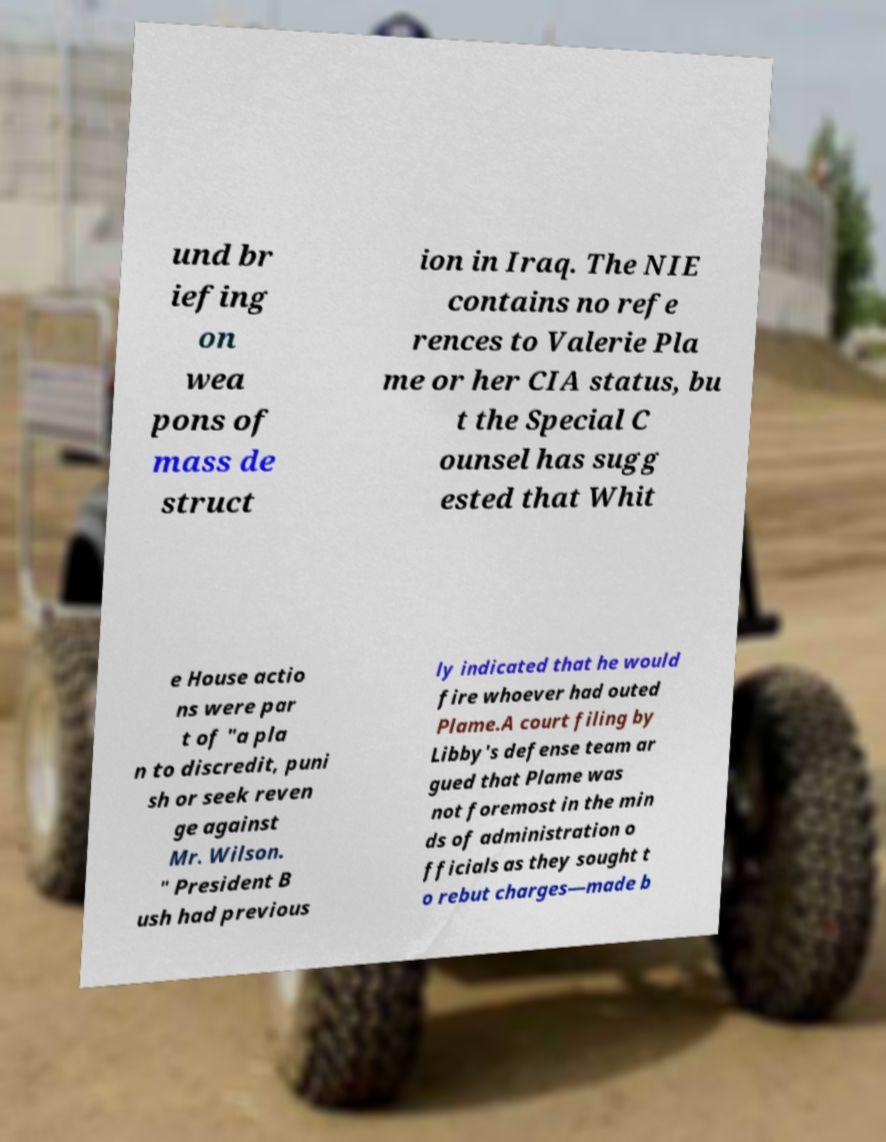Please identify and transcribe the text found in this image. und br iefing on wea pons of mass de struct ion in Iraq. The NIE contains no refe rences to Valerie Pla me or her CIA status, bu t the Special C ounsel has sugg ested that Whit e House actio ns were par t of "a pla n to discredit, puni sh or seek reven ge against Mr. Wilson. " President B ush had previous ly indicated that he would fire whoever had outed Plame.A court filing by Libby's defense team ar gued that Plame was not foremost in the min ds of administration o fficials as they sought t o rebut charges—made b 